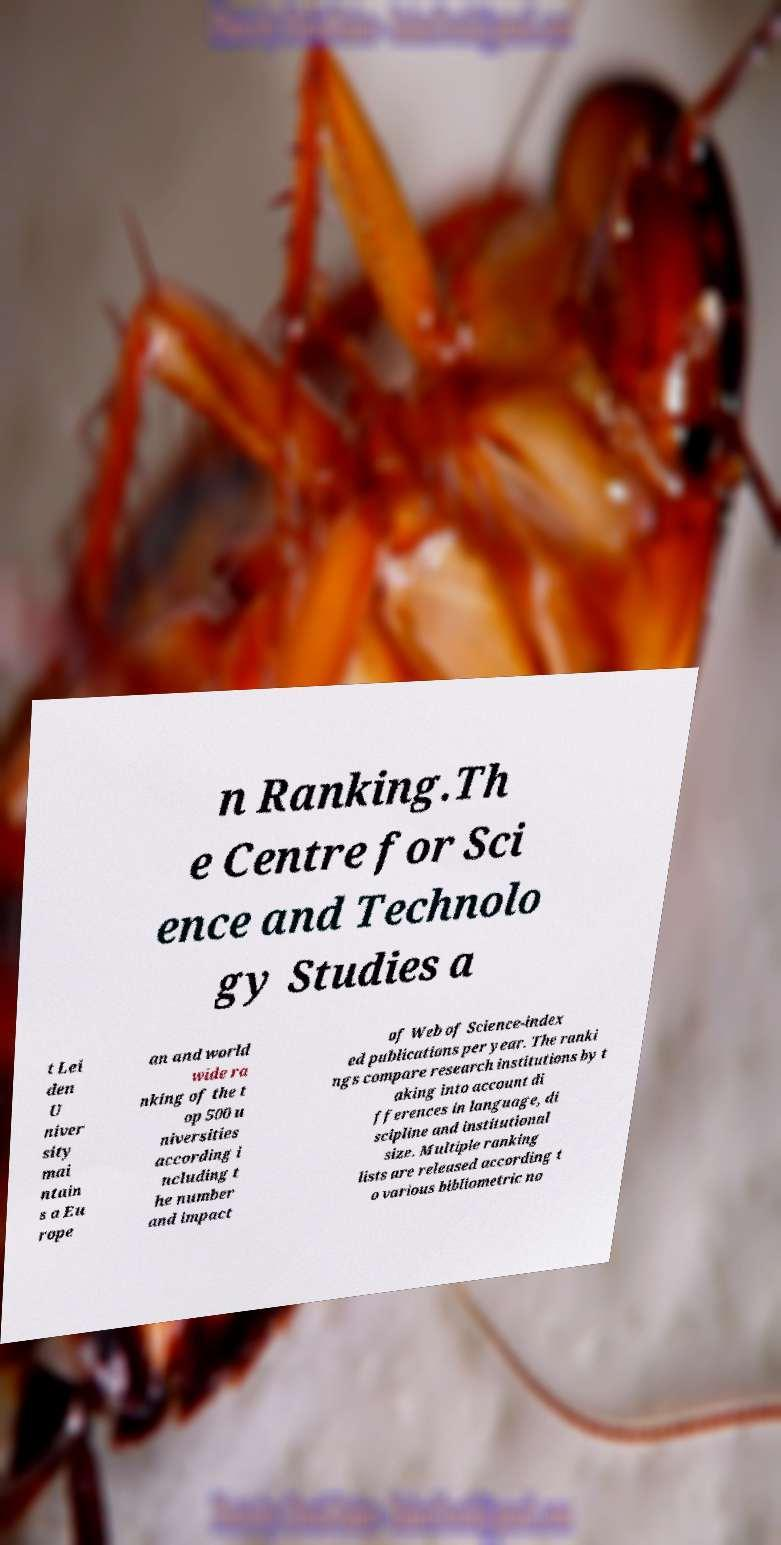There's text embedded in this image that I need extracted. Can you transcribe it verbatim? n Ranking.Th e Centre for Sci ence and Technolo gy Studies a t Lei den U niver sity mai ntain s a Eu rope an and world wide ra nking of the t op 500 u niversities according i ncluding t he number and impact of Web of Science-index ed publications per year. The ranki ngs compare research institutions by t aking into account di fferences in language, di scipline and institutional size. Multiple ranking lists are released according t o various bibliometric no 